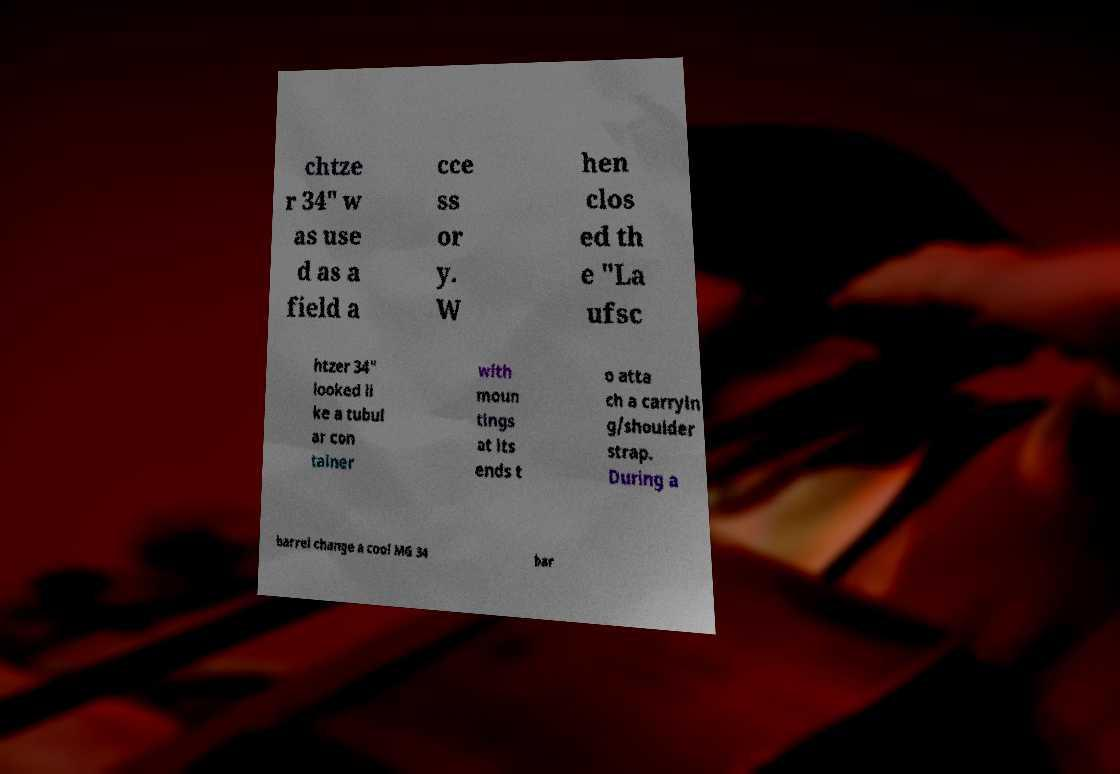Please read and relay the text visible in this image. What does it say? chtze r 34" w as use d as a field a cce ss or y. W hen clos ed th e "La ufsc htzer 34" looked li ke a tubul ar con tainer with moun tings at its ends t o atta ch a carryin g/shoulder strap. During a barrel change a cool MG 34 bar 